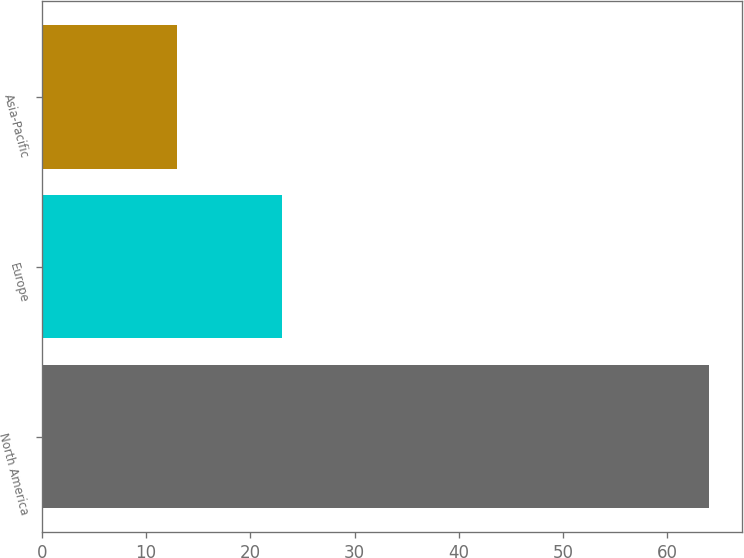Convert chart. <chart><loc_0><loc_0><loc_500><loc_500><bar_chart><fcel>North America<fcel>Europe<fcel>Asia-Pacific<nl><fcel>64<fcel>23<fcel>13<nl></chart> 